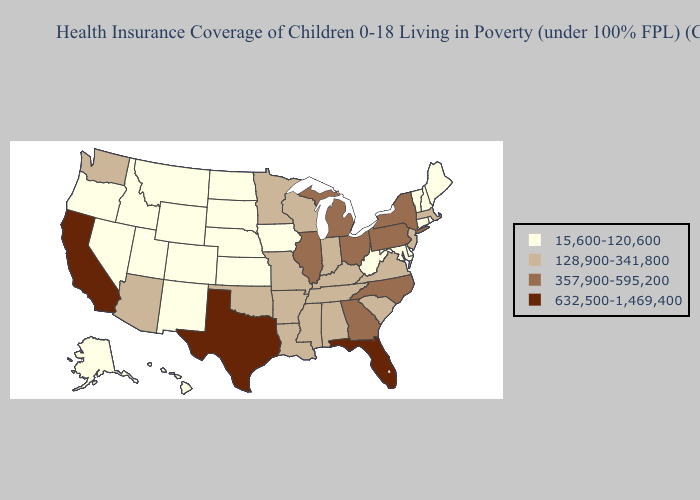Does Michigan have a higher value than North Dakota?
Short answer required. Yes. Does Illinois have the lowest value in the USA?
Write a very short answer. No. Does California have the highest value in the West?
Write a very short answer. Yes. Does Mississippi have the same value as Nebraska?
Give a very brief answer. No. What is the highest value in the USA?
Concise answer only. 632,500-1,469,400. How many symbols are there in the legend?
Short answer required. 4. Does Arizona have a higher value than Iowa?
Be succinct. Yes. Does Texas have the highest value in the USA?
Be succinct. Yes. What is the highest value in states that border South Carolina?
Concise answer only. 357,900-595,200. What is the value of Utah?
Give a very brief answer. 15,600-120,600. Name the states that have a value in the range 15,600-120,600?
Quick response, please. Alaska, Colorado, Connecticut, Delaware, Hawaii, Idaho, Iowa, Kansas, Maine, Maryland, Montana, Nebraska, Nevada, New Hampshire, New Mexico, North Dakota, Oregon, Rhode Island, South Dakota, Utah, Vermont, West Virginia, Wyoming. Name the states that have a value in the range 128,900-341,800?
Answer briefly. Alabama, Arizona, Arkansas, Indiana, Kentucky, Louisiana, Massachusetts, Minnesota, Mississippi, Missouri, New Jersey, Oklahoma, South Carolina, Tennessee, Virginia, Washington, Wisconsin. What is the value of Wisconsin?
Write a very short answer. 128,900-341,800. What is the value of Kentucky?
Concise answer only. 128,900-341,800. What is the value of Oregon?
Quick response, please. 15,600-120,600. 